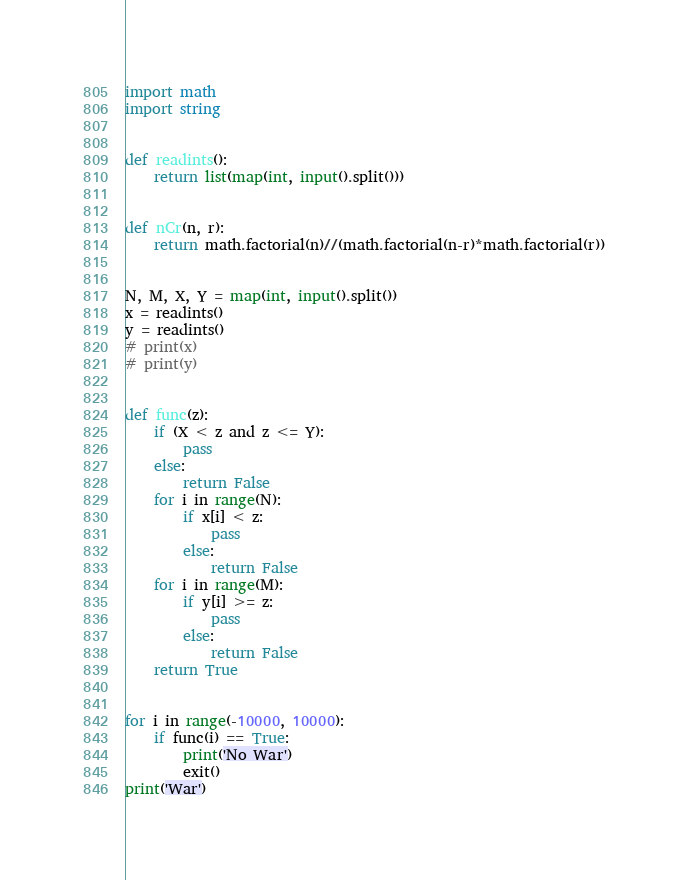Convert code to text. <code><loc_0><loc_0><loc_500><loc_500><_Python_>import math
import string


def readints():
    return list(map(int, input().split()))


def nCr(n, r):
    return math.factorial(n)//(math.factorial(n-r)*math.factorial(r))


N, M, X, Y = map(int, input().split())
x = readints()
y = readints()
# print(x)
# print(y)


def func(z):
    if (X < z and z <= Y):
        pass
    else:
        return False
    for i in range(N):
        if x[i] < z:
            pass
        else:
            return False
    for i in range(M):
        if y[i] >= z:
            pass
        else:
            return False
    return True


for i in range(-10000, 10000):
    if func(i) == True:
        print('No War')
        exit()
print('War')
</code> 